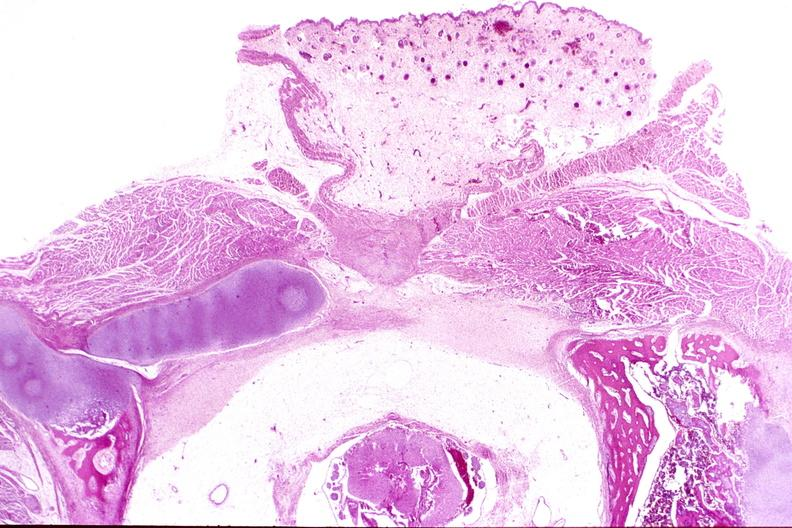what does this image show?
Answer the question using a single word or phrase. Neural tube defect 